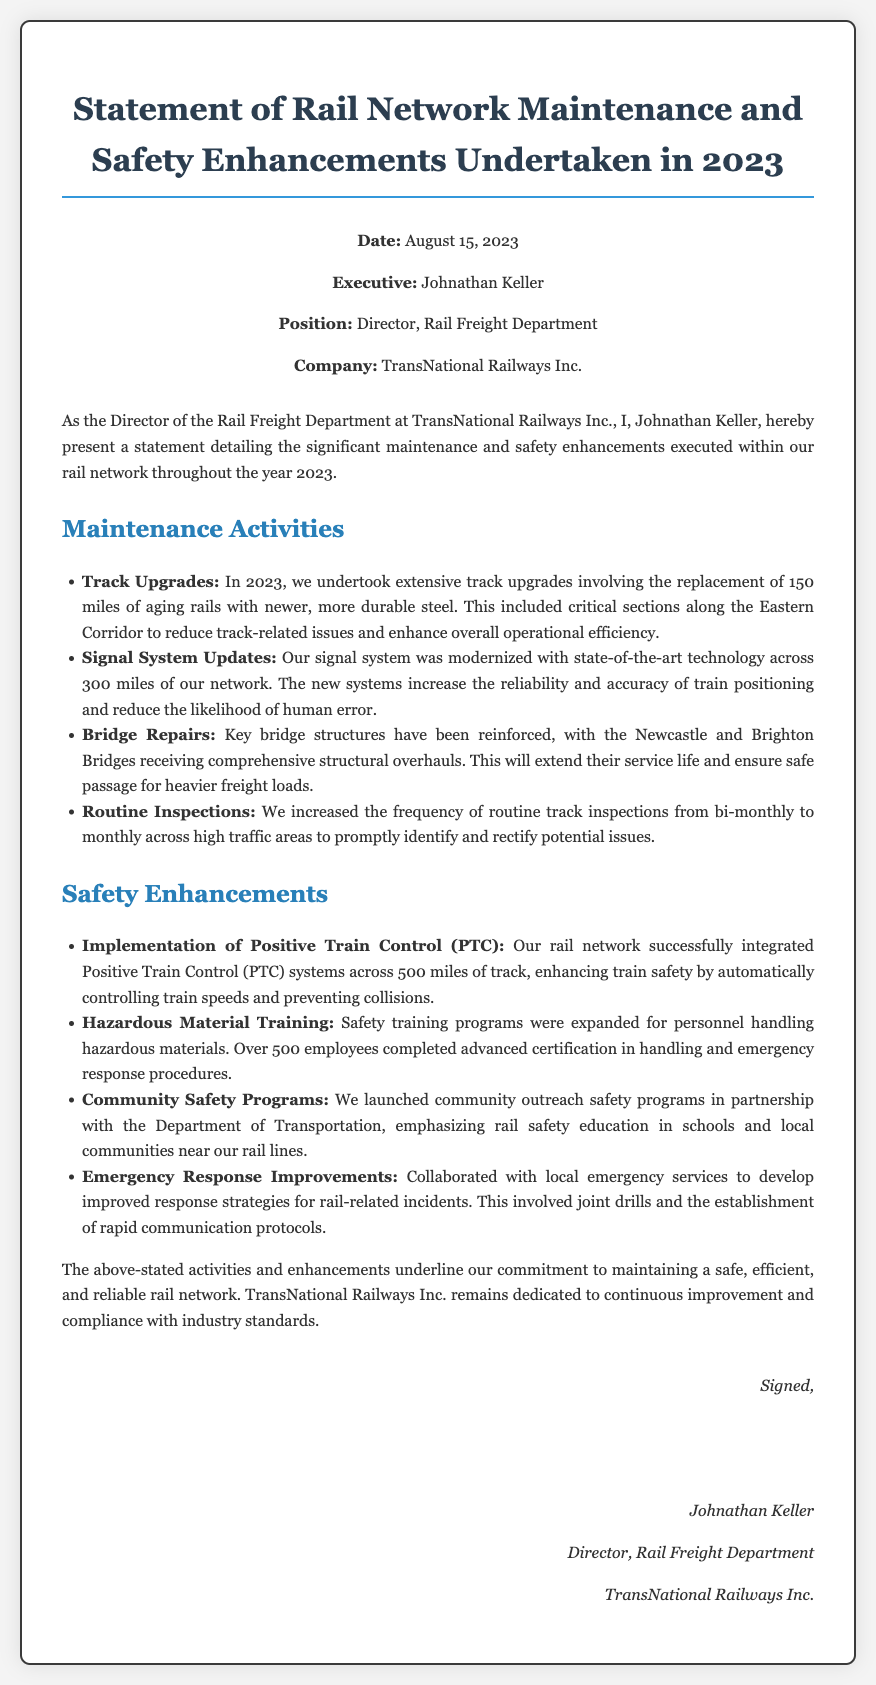What is the date of the affidavit? The affidavit states that the date is situated in the header section.
Answer: August 15, 2023 Who is the executive signing the affidavit? The executive's name is provided right below the date in the header.
Answer: Johnathan Keller What position does Johnathan Keller hold? The position is mentioned in the header section along with the executive's name.
Answer: Director, Rail Freight Department How many miles of track were upgraded in 2023? This information is found in the maintenance activities section detailing the upgrades.
Answer: 150 miles What safety system was integrated across 500 miles of track? This detail is highlighted in the safety enhancements section concerning safety measures.
Answer: Positive Train Control (PTC) Which bridges received structural overhauls? The specific bridges that were mentioned in the maintenance activities section can be found by reviewing the text.
Answer: Newcastle and Brighton Bridges How many employees completed hazardous material training? The number of employees who completed the training is indicated in the safety enhancements section.
Answer: Over 500 employees What is the company name mentioned in the affidavit? The company name is provided in the header section alongside the executive's position and name.
Answer: TransNational Railways Inc What is the purpose of the community safety programs? The document indicates that these were launched in partnership with the Department of Transportation for a specific reason.
Answer: Rail safety education 